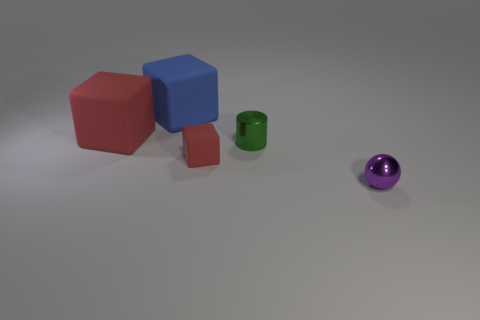Is the number of small red rubber blocks that are behind the large blue matte thing greater than the number of rubber objects?
Ensure brevity in your answer.  No. What is the tiny green cylinder made of?
Offer a terse response. Metal. What number of red matte cubes have the same size as the purple shiny sphere?
Your answer should be compact. 1. Are there an equal number of tiny metal balls left of the tiny cube and red things left of the blue thing?
Give a very brief answer. No. Does the tiny red object have the same material as the tiny green thing?
Make the answer very short. No. There is a small shiny thing on the left side of the small purple object; are there any large objects in front of it?
Your answer should be compact. No. Are there any green metal objects of the same shape as the big blue thing?
Keep it short and to the point. No. Is the ball the same color as the small cube?
Give a very brief answer. No. What material is the red block that is behind the metallic thing that is behind the purple ball made of?
Your answer should be very brief. Rubber. The blue matte cube is what size?
Your answer should be compact. Large. 